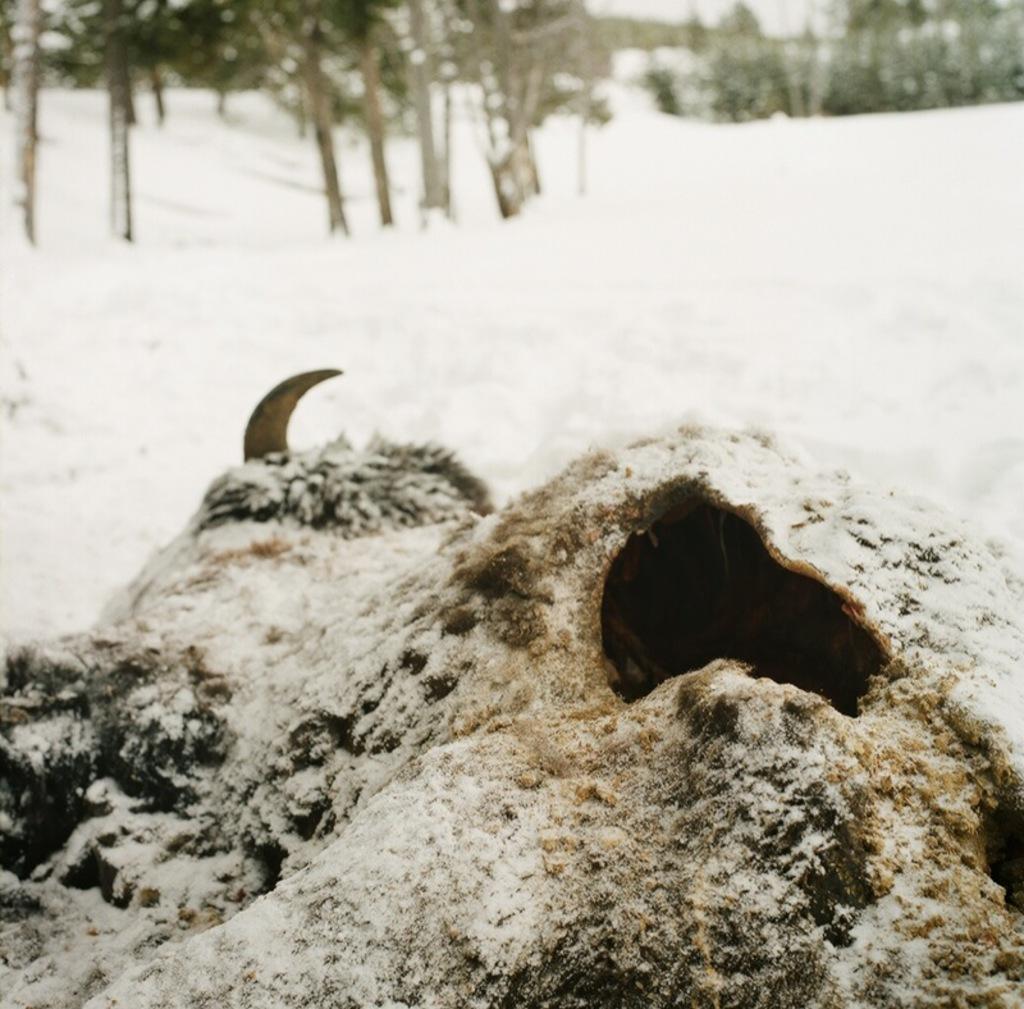How would you summarize this image in a sentence or two? Front portion of the image we can see decomposed animal. Background portion of the image we can see snow and trees. 